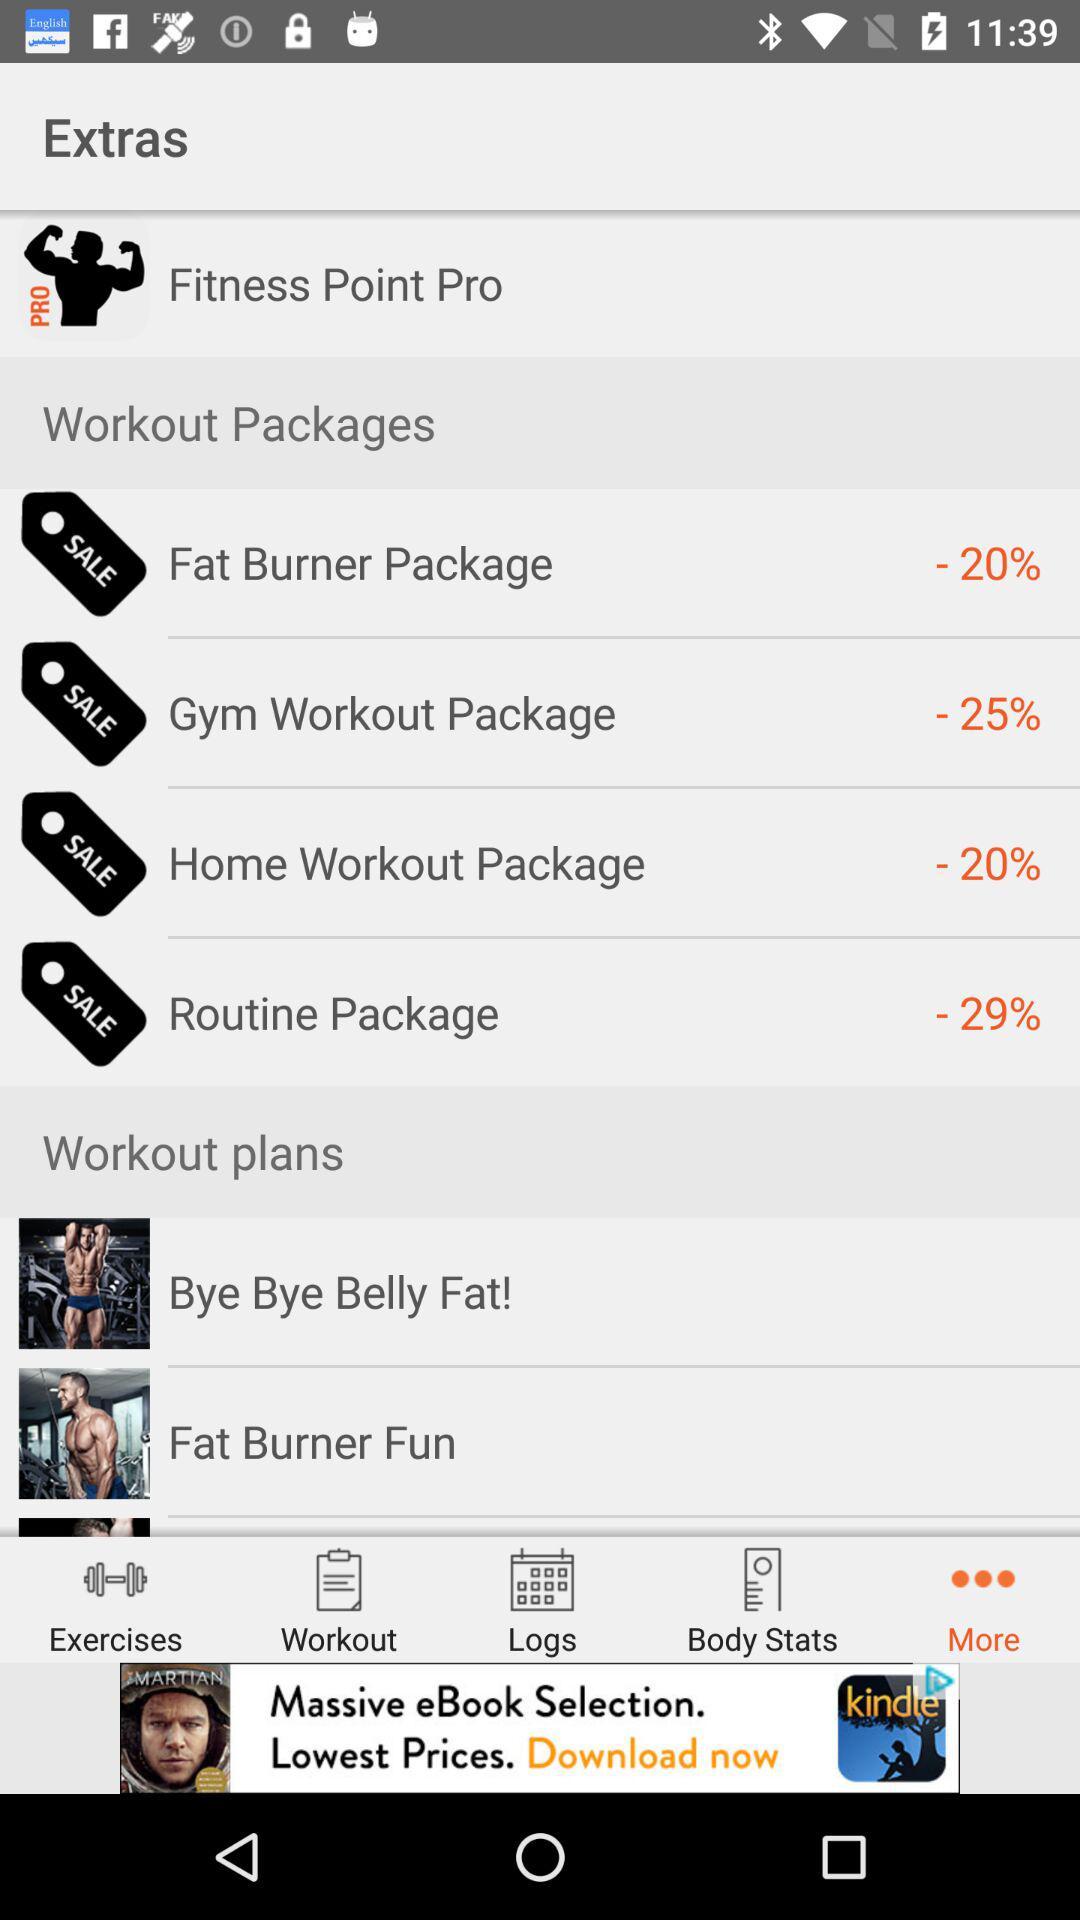What is the percentage off the Gym Workout Package?
Answer the question using a single word or phrase. -25% 